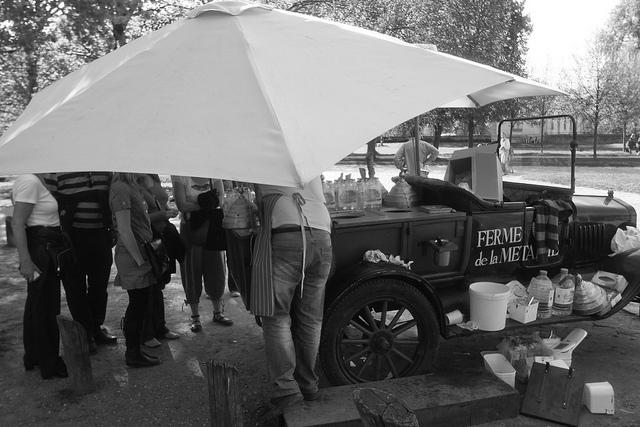Why aren't people's faces visible?
Be succinct. Umbrella. What is written on the vehicle?
Concise answer only. Ferme de la meta. Are they serving drinks?
Quick response, please. Yes. 